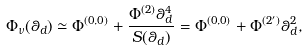<formula> <loc_0><loc_0><loc_500><loc_500>\Phi _ { \nu } ( \theta _ { d } ) \simeq \Phi ^ { ( 0 , 0 ) } + \frac { \Phi ^ { ( 2 ) } \theta _ { d } ^ { 4 } } { S ( \theta _ { d } ) } = \Phi ^ { ( 0 , 0 ) } + \Phi ^ { ( 2 ^ { \prime } ) } \theta _ { d } ^ { 2 } ,</formula> 